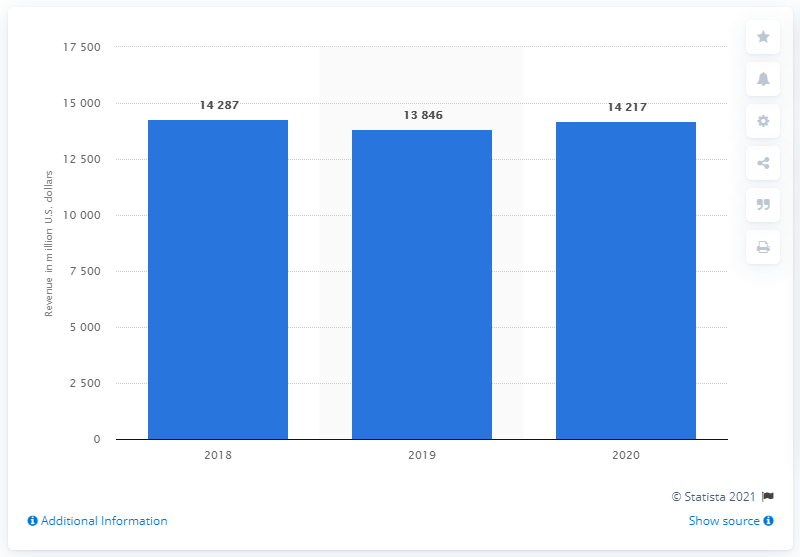Indicate a few pertinent items in this graphic. In 2020, Corteva Agriscience reported a revenue of approximately 14,217. 